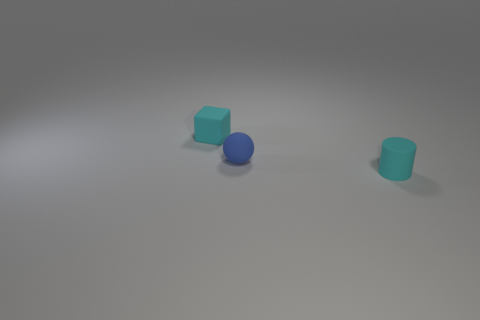Is there anything else that has the same size as the cylinder?
Offer a very short reply. Yes. Do the small blue ball that is in front of the small cyan block and the small cyan cylinder have the same material?
Make the answer very short. Yes. How many other things are there of the same color as the matte cylinder?
Make the answer very short. 1. Do the tiny cyan thing in front of the small blue rubber sphere and the cyan matte object behind the rubber cylinder have the same shape?
Offer a very short reply. No. What number of cubes are either brown matte things or small blue objects?
Provide a succinct answer. 0. Is the number of small rubber cylinders that are on the right side of the small cube less than the number of tiny balls?
Your response must be concise. No. Is the block the same size as the blue object?
Offer a very short reply. Yes. How many objects are either small cyan rubber objects that are to the right of the cyan block or big cyan matte objects?
Offer a terse response. 1. What is the material of the cube to the left of the cyan rubber thing that is in front of the cyan rubber block?
Make the answer very short. Rubber. Are there any other small blue matte things that have the same shape as the small blue matte thing?
Your answer should be compact. No. 